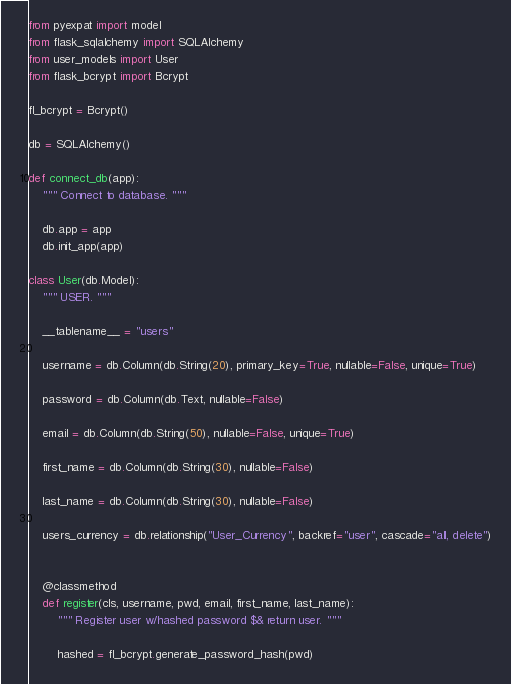<code> <loc_0><loc_0><loc_500><loc_500><_Python_>from pyexpat import model
from flask_sqlalchemy import SQLAlchemy
from user_models import User
from flask_bcrypt import Bcrypt

fl_bcrypt = Bcrypt()

db = SQLAlchemy()

def connect_db(app):
    """ Connect to database. """

    db.app = app
    db.init_app(app)

class User(db.Model):
    """ USER. """

    __tablename__ = "users"

    username = db.Column(db.String(20), primary_key=True, nullable=False, unique=True)

    password = db.Column(db.Text, nullable=False)

    email = db.Column(db.String(50), nullable=False, unique=True)

    first_name = db.Column(db.String(30), nullable=False)

    last_name = db.Column(db.String(30), nullable=False)

    users_currency = db.relationship("User_Currency", backref="user", cascade="all, delete")


    @classmethod
    def register(cls, username, pwd, email, first_name, last_name):
        """ Register user w/hashed password $& return user. """

        hashed = fl_bcrypt.generate_password_hash(pwd)</code> 